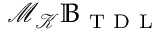<formula> <loc_0><loc_0><loc_500><loc_500>\mathcal { M } _ { \mathcal { K } } \mathbb { B } _ { T D L }</formula> 